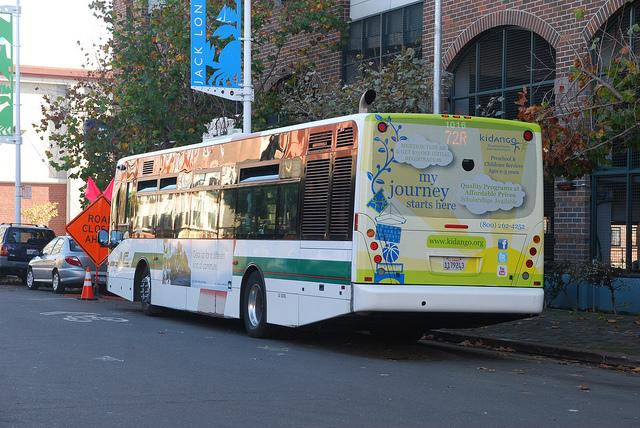What word is on the orange sign? road closed 